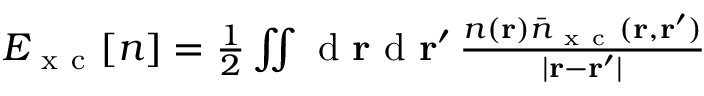Convert formula to latex. <formula><loc_0><loc_0><loc_500><loc_500>\begin{array} { r } { E _ { x c } { [ n ] } = \frac { 1 } { 2 } \iint d { r } d { r } ^ { \prime } \, \frac { n ( { r } ) \bar { n } _ { x c } ( { r } , { r } ^ { \prime } ) } { | { r } - { r } ^ { \prime } | } } \end{array}</formula> 